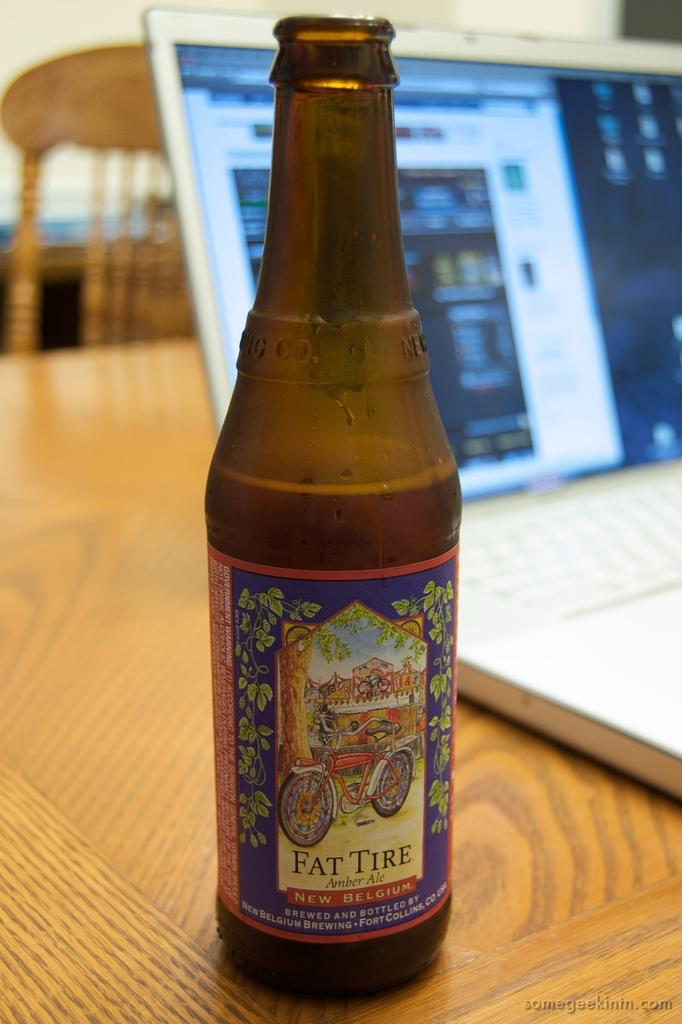<image>
Give a short and clear explanation of the subsequent image. A bottle of Fat Tire amber ale sits next to an open laptop computer. 